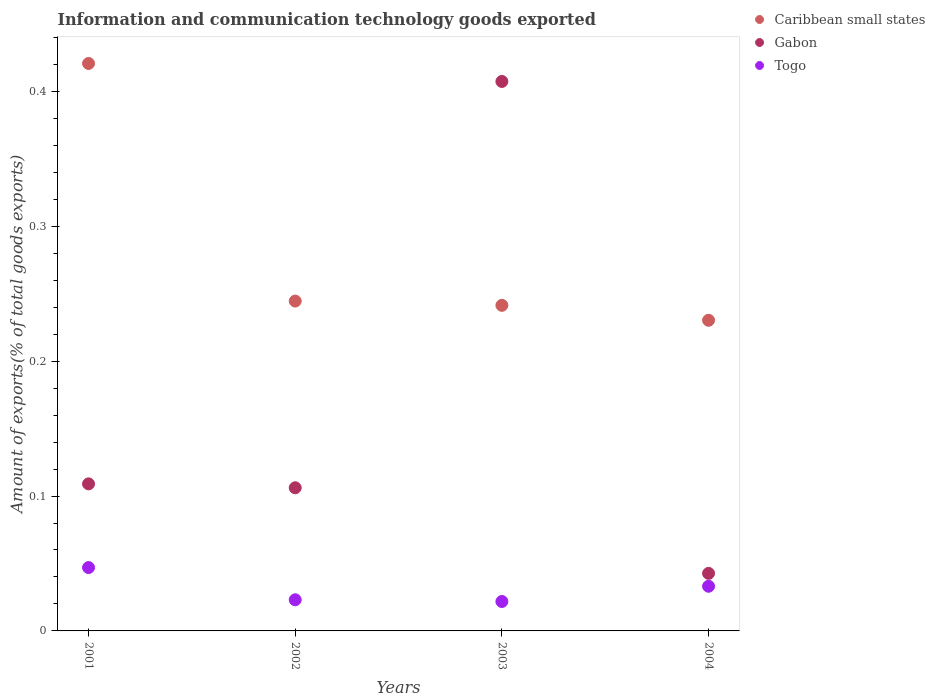Is the number of dotlines equal to the number of legend labels?
Make the answer very short. Yes. What is the amount of goods exported in Gabon in 2002?
Provide a succinct answer. 0.11. Across all years, what is the maximum amount of goods exported in Caribbean small states?
Your answer should be very brief. 0.42. Across all years, what is the minimum amount of goods exported in Gabon?
Your answer should be very brief. 0.04. In which year was the amount of goods exported in Caribbean small states minimum?
Make the answer very short. 2004. What is the total amount of goods exported in Caribbean small states in the graph?
Provide a short and direct response. 1.14. What is the difference between the amount of goods exported in Togo in 2001 and that in 2004?
Provide a short and direct response. 0.01. What is the difference between the amount of goods exported in Caribbean small states in 2002 and the amount of goods exported in Togo in 2003?
Make the answer very short. 0.22. What is the average amount of goods exported in Togo per year?
Offer a very short reply. 0.03. In the year 2003, what is the difference between the amount of goods exported in Caribbean small states and amount of goods exported in Gabon?
Your answer should be very brief. -0.17. In how many years, is the amount of goods exported in Togo greater than 0.18 %?
Keep it short and to the point. 0. What is the ratio of the amount of goods exported in Caribbean small states in 2002 to that in 2003?
Ensure brevity in your answer.  1.01. Is the amount of goods exported in Caribbean small states in 2002 less than that in 2003?
Give a very brief answer. No. Is the difference between the amount of goods exported in Caribbean small states in 2003 and 2004 greater than the difference between the amount of goods exported in Gabon in 2003 and 2004?
Give a very brief answer. No. What is the difference between the highest and the second highest amount of goods exported in Togo?
Give a very brief answer. 0.01. What is the difference between the highest and the lowest amount of goods exported in Gabon?
Provide a short and direct response. 0.36. In how many years, is the amount of goods exported in Caribbean small states greater than the average amount of goods exported in Caribbean small states taken over all years?
Your response must be concise. 1. How many years are there in the graph?
Keep it short and to the point. 4. Are the values on the major ticks of Y-axis written in scientific E-notation?
Your answer should be very brief. No. Does the graph contain any zero values?
Your answer should be compact. No. Where does the legend appear in the graph?
Offer a very short reply. Top right. What is the title of the graph?
Offer a very short reply. Information and communication technology goods exported. Does "Portugal" appear as one of the legend labels in the graph?
Ensure brevity in your answer.  No. What is the label or title of the Y-axis?
Give a very brief answer. Amount of exports(% of total goods exports). What is the Amount of exports(% of total goods exports) in Caribbean small states in 2001?
Your answer should be very brief. 0.42. What is the Amount of exports(% of total goods exports) in Gabon in 2001?
Give a very brief answer. 0.11. What is the Amount of exports(% of total goods exports) of Togo in 2001?
Keep it short and to the point. 0.05. What is the Amount of exports(% of total goods exports) of Caribbean small states in 2002?
Your answer should be very brief. 0.24. What is the Amount of exports(% of total goods exports) in Gabon in 2002?
Make the answer very short. 0.11. What is the Amount of exports(% of total goods exports) in Togo in 2002?
Offer a terse response. 0.02. What is the Amount of exports(% of total goods exports) in Caribbean small states in 2003?
Your answer should be compact. 0.24. What is the Amount of exports(% of total goods exports) of Gabon in 2003?
Offer a very short reply. 0.41. What is the Amount of exports(% of total goods exports) of Togo in 2003?
Your answer should be very brief. 0.02. What is the Amount of exports(% of total goods exports) of Caribbean small states in 2004?
Your answer should be compact. 0.23. What is the Amount of exports(% of total goods exports) in Gabon in 2004?
Provide a short and direct response. 0.04. What is the Amount of exports(% of total goods exports) in Togo in 2004?
Give a very brief answer. 0.03. Across all years, what is the maximum Amount of exports(% of total goods exports) in Caribbean small states?
Offer a very short reply. 0.42. Across all years, what is the maximum Amount of exports(% of total goods exports) of Gabon?
Your answer should be compact. 0.41. Across all years, what is the maximum Amount of exports(% of total goods exports) of Togo?
Give a very brief answer. 0.05. Across all years, what is the minimum Amount of exports(% of total goods exports) of Caribbean small states?
Keep it short and to the point. 0.23. Across all years, what is the minimum Amount of exports(% of total goods exports) of Gabon?
Ensure brevity in your answer.  0.04. Across all years, what is the minimum Amount of exports(% of total goods exports) in Togo?
Offer a very short reply. 0.02. What is the total Amount of exports(% of total goods exports) in Caribbean small states in the graph?
Your answer should be very brief. 1.14. What is the total Amount of exports(% of total goods exports) in Gabon in the graph?
Your answer should be compact. 0.67. What is the difference between the Amount of exports(% of total goods exports) in Caribbean small states in 2001 and that in 2002?
Offer a very short reply. 0.18. What is the difference between the Amount of exports(% of total goods exports) in Gabon in 2001 and that in 2002?
Keep it short and to the point. 0. What is the difference between the Amount of exports(% of total goods exports) in Togo in 2001 and that in 2002?
Provide a succinct answer. 0.02. What is the difference between the Amount of exports(% of total goods exports) of Caribbean small states in 2001 and that in 2003?
Offer a terse response. 0.18. What is the difference between the Amount of exports(% of total goods exports) in Gabon in 2001 and that in 2003?
Offer a very short reply. -0.3. What is the difference between the Amount of exports(% of total goods exports) of Togo in 2001 and that in 2003?
Your answer should be very brief. 0.03. What is the difference between the Amount of exports(% of total goods exports) in Caribbean small states in 2001 and that in 2004?
Provide a short and direct response. 0.19. What is the difference between the Amount of exports(% of total goods exports) of Gabon in 2001 and that in 2004?
Your answer should be very brief. 0.07. What is the difference between the Amount of exports(% of total goods exports) of Togo in 2001 and that in 2004?
Your answer should be very brief. 0.01. What is the difference between the Amount of exports(% of total goods exports) in Caribbean small states in 2002 and that in 2003?
Offer a very short reply. 0. What is the difference between the Amount of exports(% of total goods exports) of Gabon in 2002 and that in 2003?
Your answer should be compact. -0.3. What is the difference between the Amount of exports(% of total goods exports) in Togo in 2002 and that in 2003?
Offer a very short reply. 0. What is the difference between the Amount of exports(% of total goods exports) of Caribbean small states in 2002 and that in 2004?
Offer a terse response. 0.01. What is the difference between the Amount of exports(% of total goods exports) of Gabon in 2002 and that in 2004?
Your answer should be compact. 0.06. What is the difference between the Amount of exports(% of total goods exports) in Togo in 2002 and that in 2004?
Provide a short and direct response. -0.01. What is the difference between the Amount of exports(% of total goods exports) of Caribbean small states in 2003 and that in 2004?
Your answer should be very brief. 0.01. What is the difference between the Amount of exports(% of total goods exports) in Gabon in 2003 and that in 2004?
Offer a terse response. 0.36. What is the difference between the Amount of exports(% of total goods exports) of Togo in 2003 and that in 2004?
Make the answer very short. -0.01. What is the difference between the Amount of exports(% of total goods exports) of Caribbean small states in 2001 and the Amount of exports(% of total goods exports) of Gabon in 2002?
Offer a terse response. 0.31. What is the difference between the Amount of exports(% of total goods exports) of Caribbean small states in 2001 and the Amount of exports(% of total goods exports) of Togo in 2002?
Your answer should be very brief. 0.4. What is the difference between the Amount of exports(% of total goods exports) of Gabon in 2001 and the Amount of exports(% of total goods exports) of Togo in 2002?
Ensure brevity in your answer.  0.09. What is the difference between the Amount of exports(% of total goods exports) of Caribbean small states in 2001 and the Amount of exports(% of total goods exports) of Gabon in 2003?
Offer a very short reply. 0.01. What is the difference between the Amount of exports(% of total goods exports) in Caribbean small states in 2001 and the Amount of exports(% of total goods exports) in Togo in 2003?
Provide a short and direct response. 0.4. What is the difference between the Amount of exports(% of total goods exports) in Gabon in 2001 and the Amount of exports(% of total goods exports) in Togo in 2003?
Offer a terse response. 0.09. What is the difference between the Amount of exports(% of total goods exports) of Caribbean small states in 2001 and the Amount of exports(% of total goods exports) of Gabon in 2004?
Keep it short and to the point. 0.38. What is the difference between the Amount of exports(% of total goods exports) of Caribbean small states in 2001 and the Amount of exports(% of total goods exports) of Togo in 2004?
Your answer should be compact. 0.39. What is the difference between the Amount of exports(% of total goods exports) of Gabon in 2001 and the Amount of exports(% of total goods exports) of Togo in 2004?
Your answer should be compact. 0.08. What is the difference between the Amount of exports(% of total goods exports) in Caribbean small states in 2002 and the Amount of exports(% of total goods exports) in Gabon in 2003?
Provide a short and direct response. -0.16. What is the difference between the Amount of exports(% of total goods exports) of Caribbean small states in 2002 and the Amount of exports(% of total goods exports) of Togo in 2003?
Give a very brief answer. 0.22. What is the difference between the Amount of exports(% of total goods exports) in Gabon in 2002 and the Amount of exports(% of total goods exports) in Togo in 2003?
Make the answer very short. 0.08. What is the difference between the Amount of exports(% of total goods exports) in Caribbean small states in 2002 and the Amount of exports(% of total goods exports) in Gabon in 2004?
Provide a succinct answer. 0.2. What is the difference between the Amount of exports(% of total goods exports) of Caribbean small states in 2002 and the Amount of exports(% of total goods exports) of Togo in 2004?
Give a very brief answer. 0.21. What is the difference between the Amount of exports(% of total goods exports) in Gabon in 2002 and the Amount of exports(% of total goods exports) in Togo in 2004?
Your answer should be very brief. 0.07. What is the difference between the Amount of exports(% of total goods exports) in Caribbean small states in 2003 and the Amount of exports(% of total goods exports) in Gabon in 2004?
Give a very brief answer. 0.2. What is the difference between the Amount of exports(% of total goods exports) of Caribbean small states in 2003 and the Amount of exports(% of total goods exports) of Togo in 2004?
Ensure brevity in your answer.  0.21. What is the difference between the Amount of exports(% of total goods exports) of Gabon in 2003 and the Amount of exports(% of total goods exports) of Togo in 2004?
Offer a very short reply. 0.37. What is the average Amount of exports(% of total goods exports) in Caribbean small states per year?
Keep it short and to the point. 0.28. What is the average Amount of exports(% of total goods exports) of Gabon per year?
Offer a terse response. 0.17. What is the average Amount of exports(% of total goods exports) of Togo per year?
Ensure brevity in your answer.  0.03. In the year 2001, what is the difference between the Amount of exports(% of total goods exports) of Caribbean small states and Amount of exports(% of total goods exports) of Gabon?
Your answer should be very brief. 0.31. In the year 2001, what is the difference between the Amount of exports(% of total goods exports) of Caribbean small states and Amount of exports(% of total goods exports) of Togo?
Provide a short and direct response. 0.37. In the year 2001, what is the difference between the Amount of exports(% of total goods exports) in Gabon and Amount of exports(% of total goods exports) in Togo?
Keep it short and to the point. 0.06. In the year 2002, what is the difference between the Amount of exports(% of total goods exports) of Caribbean small states and Amount of exports(% of total goods exports) of Gabon?
Your response must be concise. 0.14. In the year 2002, what is the difference between the Amount of exports(% of total goods exports) of Caribbean small states and Amount of exports(% of total goods exports) of Togo?
Make the answer very short. 0.22. In the year 2002, what is the difference between the Amount of exports(% of total goods exports) of Gabon and Amount of exports(% of total goods exports) of Togo?
Keep it short and to the point. 0.08. In the year 2003, what is the difference between the Amount of exports(% of total goods exports) of Caribbean small states and Amount of exports(% of total goods exports) of Gabon?
Your answer should be compact. -0.17. In the year 2003, what is the difference between the Amount of exports(% of total goods exports) of Caribbean small states and Amount of exports(% of total goods exports) of Togo?
Your answer should be very brief. 0.22. In the year 2003, what is the difference between the Amount of exports(% of total goods exports) of Gabon and Amount of exports(% of total goods exports) of Togo?
Offer a very short reply. 0.39. In the year 2004, what is the difference between the Amount of exports(% of total goods exports) in Caribbean small states and Amount of exports(% of total goods exports) in Gabon?
Ensure brevity in your answer.  0.19. In the year 2004, what is the difference between the Amount of exports(% of total goods exports) in Caribbean small states and Amount of exports(% of total goods exports) in Togo?
Provide a succinct answer. 0.2. In the year 2004, what is the difference between the Amount of exports(% of total goods exports) in Gabon and Amount of exports(% of total goods exports) in Togo?
Give a very brief answer. 0.01. What is the ratio of the Amount of exports(% of total goods exports) in Caribbean small states in 2001 to that in 2002?
Keep it short and to the point. 1.72. What is the ratio of the Amount of exports(% of total goods exports) of Gabon in 2001 to that in 2002?
Your answer should be very brief. 1.03. What is the ratio of the Amount of exports(% of total goods exports) in Togo in 2001 to that in 2002?
Your response must be concise. 2.04. What is the ratio of the Amount of exports(% of total goods exports) in Caribbean small states in 2001 to that in 2003?
Your answer should be very brief. 1.74. What is the ratio of the Amount of exports(% of total goods exports) in Gabon in 2001 to that in 2003?
Your answer should be compact. 0.27. What is the ratio of the Amount of exports(% of total goods exports) of Togo in 2001 to that in 2003?
Make the answer very short. 2.15. What is the ratio of the Amount of exports(% of total goods exports) in Caribbean small states in 2001 to that in 2004?
Provide a short and direct response. 1.83. What is the ratio of the Amount of exports(% of total goods exports) in Gabon in 2001 to that in 2004?
Your answer should be very brief. 2.56. What is the ratio of the Amount of exports(% of total goods exports) in Togo in 2001 to that in 2004?
Make the answer very short. 1.42. What is the ratio of the Amount of exports(% of total goods exports) in Caribbean small states in 2002 to that in 2003?
Provide a succinct answer. 1.01. What is the ratio of the Amount of exports(% of total goods exports) in Gabon in 2002 to that in 2003?
Your answer should be compact. 0.26. What is the ratio of the Amount of exports(% of total goods exports) of Togo in 2002 to that in 2003?
Offer a very short reply. 1.06. What is the ratio of the Amount of exports(% of total goods exports) in Caribbean small states in 2002 to that in 2004?
Your response must be concise. 1.06. What is the ratio of the Amount of exports(% of total goods exports) in Gabon in 2002 to that in 2004?
Your response must be concise. 2.49. What is the ratio of the Amount of exports(% of total goods exports) in Togo in 2002 to that in 2004?
Keep it short and to the point. 0.7. What is the ratio of the Amount of exports(% of total goods exports) of Caribbean small states in 2003 to that in 2004?
Offer a very short reply. 1.05. What is the ratio of the Amount of exports(% of total goods exports) in Gabon in 2003 to that in 2004?
Your answer should be compact. 9.55. What is the ratio of the Amount of exports(% of total goods exports) in Togo in 2003 to that in 2004?
Make the answer very short. 0.66. What is the difference between the highest and the second highest Amount of exports(% of total goods exports) of Caribbean small states?
Provide a succinct answer. 0.18. What is the difference between the highest and the second highest Amount of exports(% of total goods exports) of Gabon?
Provide a succinct answer. 0.3. What is the difference between the highest and the second highest Amount of exports(% of total goods exports) of Togo?
Your answer should be very brief. 0.01. What is the difference between the highest and the lowest Amount of exports(% of total goods exports) of Caribbean small states?
Provide a short and direct response. 0.19. What is the difference between the highest and the lowest Amount of exports(% of total goods exports) of Gabon?
Offer a very short reply. 0.36. What is the difference between the highest and the lowest Amount of exports(% of total goods exports) in Togo?
Your answer should be compact. 0.03. 